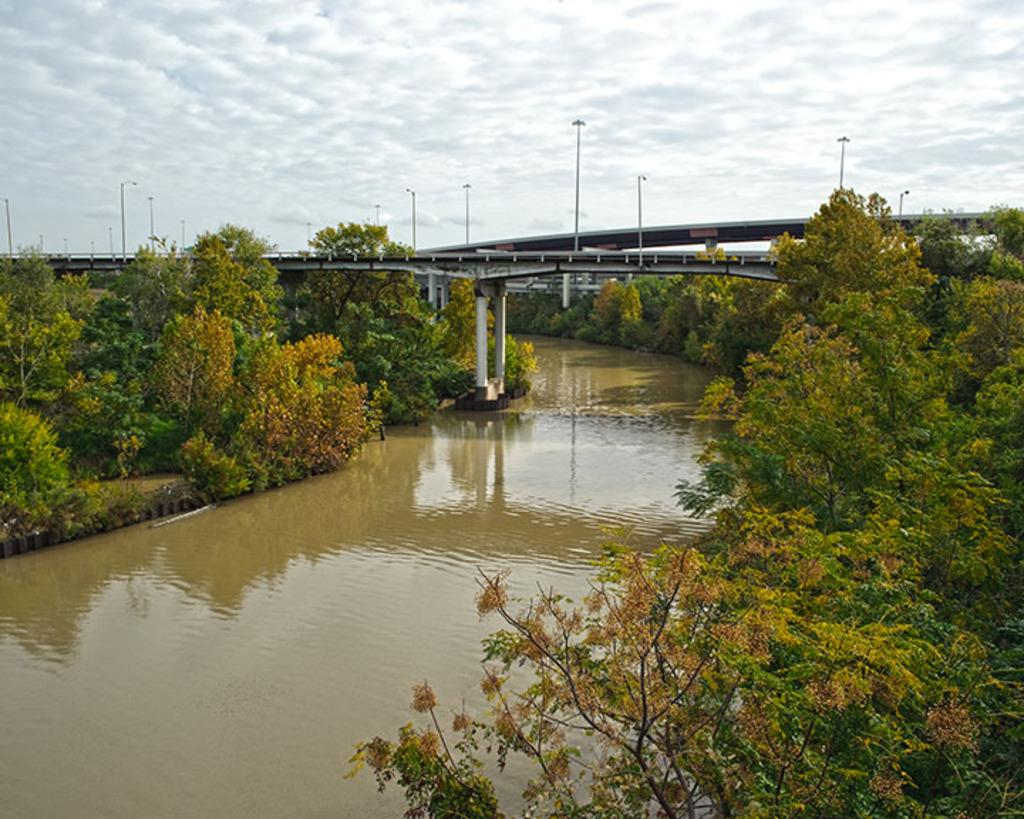What type of body of water is present in the image? There is a lake in the image. What type of vegetation can be seen in the image? There are trees and plants in the image. What structure is present in the image? There is a bridge in the image. What are the poles used for in the image? The purpose of the poles is not specified in the image. What is the condition of the sky in the image? The sky is clear in the image. What type of glass is used to represent the lake in the image? There is no glass present in the image; it is a real lake. How much dust can be seen on the trees in the image? There is no dust visible on the trees in the image. 